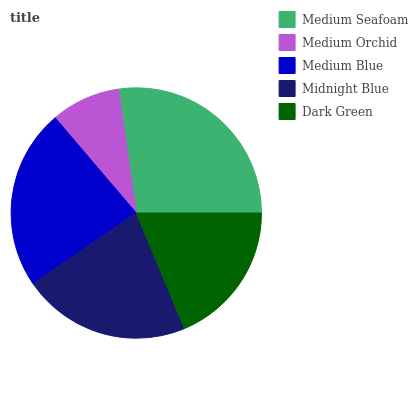Is Medium Orchid the minimum?
Answer yes or no. Yes. Is Medium Seafoam the maximum?
Answer yes or no. Yes. Is Medium Blue the minimum?
Answer yes or no. No. Is Medium Blue the maximum?
Answer yes or no. No. Is Medium Blue greater than Medium Orchid?
Answer yes or no. Yes. Is Medium Orchid less than Medium Blue?
Answer yes or no. Yes. Is Medium Orchid greater than Medium Blue?
Answer yes or no. No. Is Medium Blue less than Medium Orchid?
Answer yes or no. No. Is Midnight Blue the high median?
Answer yes or no. Yes. Is Midnight Blue the low median?
Answer yes or no. Yes. Is Medium Blue the high median?
Answer yes or no. No. Is Medium Blue the low median?
Answer yes or no. No. 